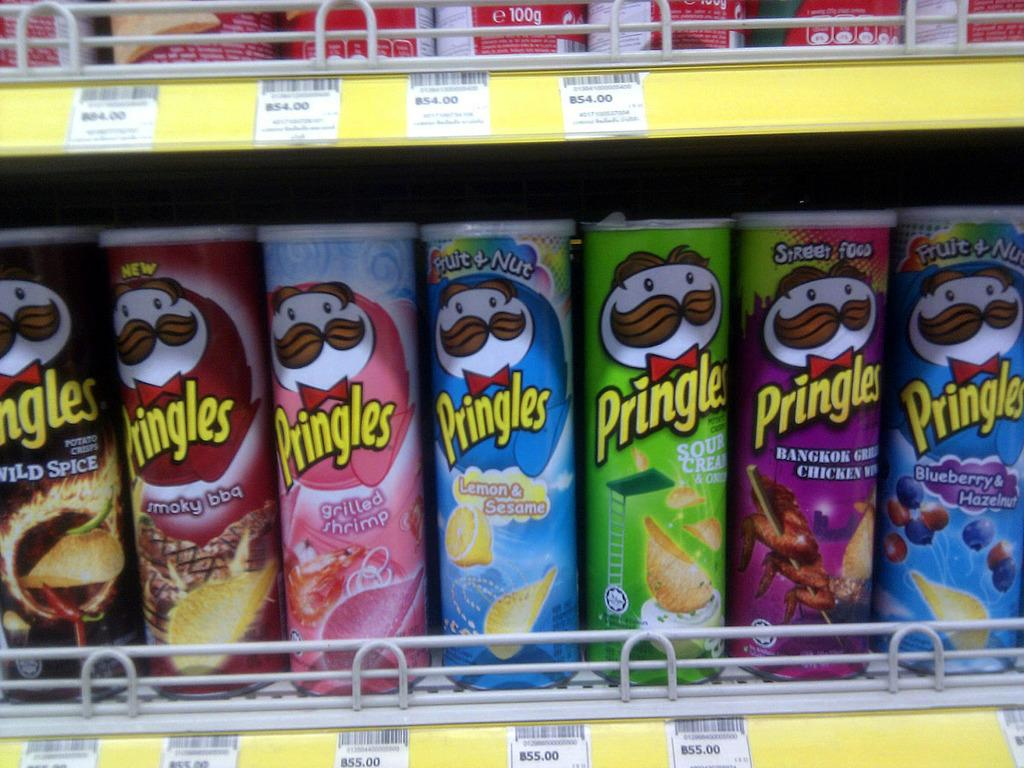Provide a one-sentence caption for the provided image. Several cans of Pringles chips sitting on a store shelf with prices underneath. 